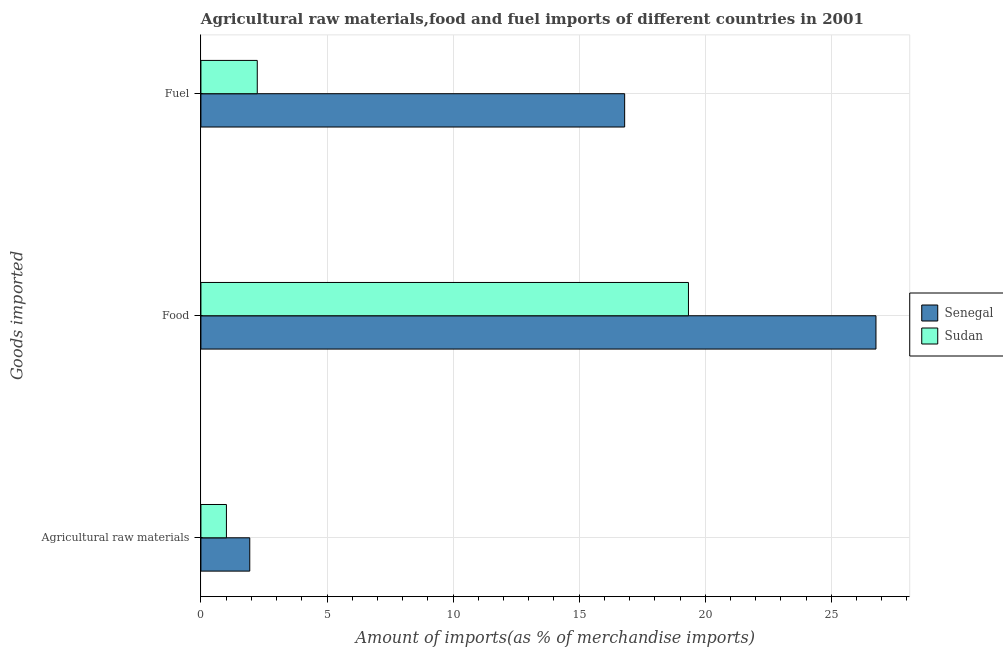How many different coloured bars are there?
Ensure brevity in your answer.  2. How many groups of bars are there?
Keep it short and to the point. 3. What is the label of the 3rd group of bars from the top?
Your answer should be compact. Agricultural raw materials. What is the percentage of food imports in Senegal?
Ensure brevity in your answer.  26.77. Across all countries, what is the maximum percentage of raw materials imports?
Offer a very short reply. 1.94. Across all countries, what is the minimum percentage of raw materials imports?
Your response must be concise. 1.01. In which country was the percentage of food imports maximum?
Provide a succinct answer. Senegal. In which country was the percentage of raw materials imports minimum?
Provide a short and direct response. Sudan. What is the total percentage of food imports in the graph?
Offer a terse response. 46.11. What is the difference between the percentage of food imports in Sudan and that in Senegal?
Your answer should be very brief. -7.44. What is the difference between the percentage of fuel imports in Sudan and the percentage of raw materials imports in Senegal?
Offer a terse response. 0.3. What is the average percentage of food imports per country?
Offer a terse response. 23.05. What is the difference between the percentage of food imports and percentage of fuel imports in Sudan?
Provide a short and direct response. 17.1. In how many countries, is the percentage of fuel imports greater than 1 %?
Provide a succinct answer. 2. What is the ratio of the percentage of raw materials imports in Senegal to that in Sudan?
Your response must be concise. 1.92. Is the difference between the percentage of food imports in Sudan and Senegal greater than the difference between the percentage of fuel imports in Sudan and Senegal?
Keep it short and to the point. Yes. What is the difference between the highest and the second highest percentage of fuel imports?
Your response must be concise. 14.57. What is the difference between the highest and the lowest percentage of food imports?
Your answer should be very brief. 7.44. In how many countries, is the percentage of raw materials imports greater than the average percentage of raw materials imports taken over all countries?
Make the answer very short. 1. Is the sum of the percentage of food imports in Sudan and Senegal greater than the maximum percentage of fuel imports across all countries?
Your answer should be very brief. Yes. What does the 2nd bar from the top in Food represents?
Offer a terse response. Senegal. What does the 2nd bar from the bottom in Fuel represents?
Offer a terse response. Sudan. Are all the bars in the graph horizontal?
Offer a very short reply. Yes. Are the values on the major ticks of X-axis written in scientific E-notation?
Keep it short and to the point. No. Does the graph contain grids?
Offer a terse response. Yes. Where does the legend appear in the graph?
Give a very brief answer. Center right. What is the title of the graph?
Ensure brevity in your answer.  Agricultural raw materials,food and fuel imports of different countries in 2001. Does "Low income" appear as one of the legend labels in the graph?
Provide a short and direct response. No. What is the label or title of the X-axis?
Ensure brevity in your answer.  Amount of imports(as % of merchandise imports). What is the label or title of the Y-axis?
Provide a short and direct response. Goods imported. What is the Amount of imports(as % of merchandise imports) of Senegal in Agricultural raw materials?
Provide a succinct answer. 1.94. What is the Amount of imports(as % of merchandise imports) in Sudan in Agricultural raw materials?
Provide a short and direct response. 1.01. What is the Amount of imports(as % of merchandise imports) in Senegal in Food?
Ensure brevity in your answer.  26.77. What is the Amount of imports(as % of merchandise imports) in Sudan in Food?
Provide a succinct answer. 19.33. What is the Amount of imports(as % of merchandise imports) in Senegal in Fuel?
Keep it short and to the point. 16.8. What is the Amount of imports(as % of merchandise imports) of Sudan in Fuel?
Keep it short and to the point. 2.23. Across all Goods imported, what is the maximum Amount of imports(as % of merchandise imports) in Senegal?
Provide a short and direct response. 26.77. Across all Goods imported, what is the maximum Amount of imports(as % of merchandise imports) in Sudan?
Your answer should be compact. 19.33. Across all Goods imported, what is the minimum Amount of imports(as % of merchandise imports) in Senegal?
Keep it short and to the point. 1.94. Across all Goods imported, what is the minimum Amount of imports(as % of merchandise imports) in Sudan?
Provide a succinct answer. 1.01. What is the total Amount of imports(as % of merchandise imports) in Senegal in the graph?
Your answer should be compact. 45.51. What is the total Amount of imports(as % of merchandise imports) in Sudan in the graph?
Keep it short and to the point. 22.58. What is the difference between the Amount of imports(as % of merchandise imports) in Senegal in Agricultural raw materials and that in Food?
Your answer should be very brief. -24.83. What is the difference between the Amount of imports(as % of merchandise imports) of Sudan in Agricultural raw materials and that in Food?
Offer a very short reply. -18.32. What is the difference between the Amount of imports(as % of merchandise imports) of Senegal in Agricultural raw materials and that in Fuel?
Your response must be concise. -14.87. What is the difference between the Amount of imports(as % of merchandise imports) of Sudan in Agricultural raw materials and that in Fuel?
Offer a terse response. -1.22. What is the difference between the Amount of imports(as % of merchandise imports) of Senegal in Food and that in Fuel?
Give a very brief answer. 9.97. What is the difference between the Amount of imports(as % of merchandise imports) of Senegal in Agricultural raw materials and the Amount of imports(as % of merchandise imports) of Sudan in Food?
Your answer should be compact. -17.4. What is the difference between the Amount of imports(as % of merchandise imports) in Senegal in Agricultural raw materials and the Amount of imports(as % of merchandise imports) in Sudan in Fuel?
Your response must be concise. -0.3. What is the difference between the Amount of imports(as % of merchandise imports) of Senegal in Food and the Amount of imports(as % of merchandise imports) of Sudan in Fuel?
Your answer should be compact. 24.54. What is the average Amount of imports(as % of merchandise imports) of Senegal per Goods imported?
Provide a succinct answer. 15.17. What is the average Amount of imports(as % of merchandise imports) in Sudan per Goods imported?
Provide a succinct answer. 7.53. What is the difference between the Amount of imports(as % of merchandise imports) in Senegal and Amount of imports(as % of merchandise imports) in Sudan in Agricultural raw materials?
Your answer should be very brief. 0.93. What is the difference between the Amount of imports(as % of merchandise imports) of Senegal and Amount of imports(as % of merchandise imports) of Sudan in Food?
Your answer should be very brief. 7.44. What is the difference between the Amount of imports(as % of merchandise imports) of Senegal and Amount of imports(as % of merchandise imports) of Sudan in Fuel?
Keep it short and to the point. 14.57. What is the ratio of the Amount of imports(as % of merchandise imports) of Senegal in Agricultural raw materials to that in Food?
Offer a terse response. 0.07. What is the ratio of the Amount of imports(as % of merchandise imports) in Sudan in Agricultural raw materials to that in Food?
Your answer should be very brief. 0.05. What is the ratio of the Amount of imports(as % of merchandise imports) of Senegal in Agricultural raw materials to that in Fuel?
Your answer should be very brief. 0.12. What is the ratio of the Amount of imports(as % of merchandise imports) in Sudan in Agricultural raw materials to that in Fuel?
Your answer should be very brief. 0.45. What is the ratio of the Amount of imports(as % of merchandise imports) in Senegal in Food to that in Fuel?
Keep it short and to the point. 1.59. What is the ratio of the Amount of imports(as % of merchandise imports) of Sudan in Food to that in Fuel?
Give a very brief answer. 8.65. What is the difference between the highest and the second highest Amount of imports(as % of merchandise imports) of Senegal?
Ensure brevity in your answer.  9.97. What is the difference between the highest and the lowest Amount of imports(as % of merchandise imports) of Senegal?
Offer a terse response. 24.83. What is the difference between the highest and the lowest Amount of imports(as % of merchandise imports) in Sudan?
Your answer should be compact. 18.32. 